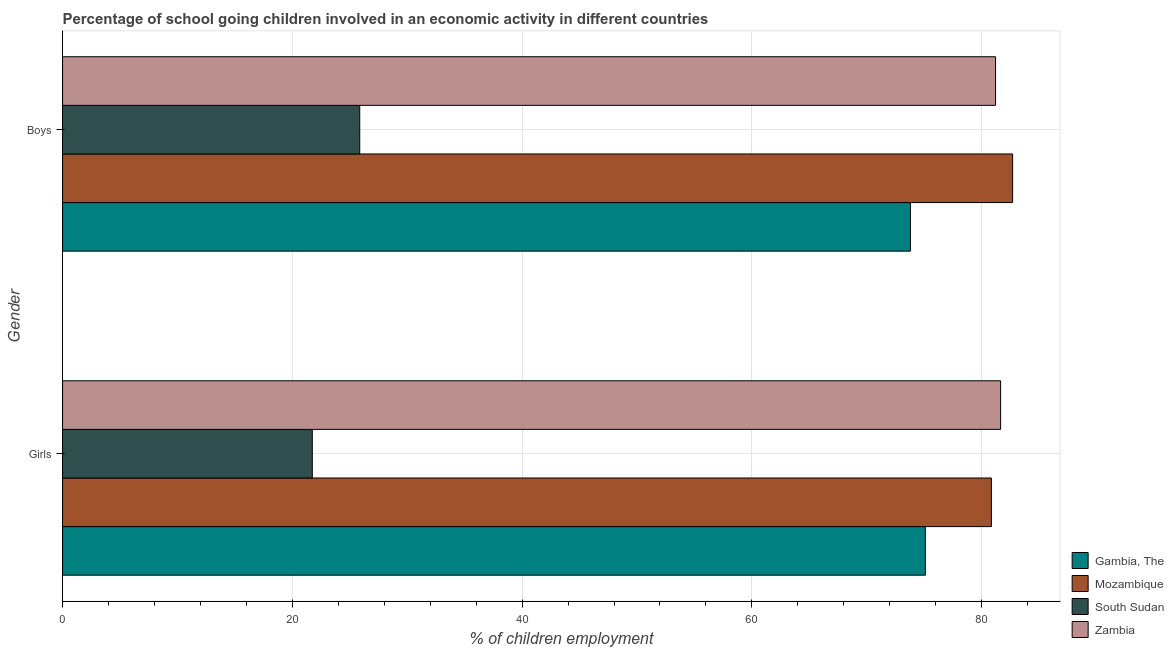How many different coloured bars are there?
Provide a short and direct response. 4. How many groups of bars are there?
Your response must be concise. 2. How many bars are there on the 2nd tick from the top?
Ensure brevity in your answer.  4. What is the label of the 2nd group of bars from the top?
Your answer should be compact. Girls. What is the percentage of school going girls in Gambia, The?
Your answer should be very brief. 75.1. Across all countries, what is the maximum percentage of school going girls?
Give a very brief answer. 81.65. Across all countries, what is the minimum percentage of school going girls?
Offer a terse response. 21.74. In which country was the percentage of school going girls maximum?
Provide a short and direct response. Zambia. In which country was the percentage of school going girls minimum?
Provide a short and direct response. South Sudan. What is the total percentage of school going girls in the graph?
Provide a succinct answer. 259.34. What is the difference between the percentage of school going girls in Gambia, The and that in Mozambique?
Keep it short and to the point. -5.75. What is the difference between the percentage of school going girls in South Sudan and the percentage of school going boys in Gambia, The?
Ensure brevity in your answer.  -52.06. What is the average percentage of school going boys per country?
Make the answer very short. 65.89. What is the difference between the percentage of school going boys and percentage of school going girls in Zambia?
Offer a very short reply. -0.44. What is the ratio of the percentage of school going boys in Mozambique to that in Zambia?
Offer a terse response. 1.02. Is the percentage of school going girls in Mozambique less than that in South Sudan?
Make the answer very short. No. What does the 4th bar from the top in Girls represents?
Offer a terse response. Gambia, The. What does the 3rd bar from the bottom in Girls represents?
Offer a terse response. South Sudan. How many bars are there?
Your answer should be very brief. 8. Are all the bars in the graph horizontal?
Keep it short and to the point. Yes. How many countries are there in the graph?
Make the answer very short. 4. Are the values on the major ticks of X-axis written in scientific E-notation?
Your response must be concise. No. Does the graph contain grids?
Offer a terse response. Yes. Where does the legend appear in the graph?
Make the answer very short. Bottom right. How many legend labels are there?
Make the answer very short. 4. What is the title of the graph?
Offer a terse response. Percentage of school going children involved in an economic activity in different countries. Does "Nicaragua" appear as one of the legend labels in the graph?
Provide a succinct answer. No. What is the label or title of the X-axis?
Provide a short and direct response. % of children employment. What is the label or title of the Y-axis?
Give a very brief answer. Gender. What is the % of children employment in Gambia, The in Girls?
Keep it short and to the point. 75.1. What is the % of children employment of Mozambique in Girls?
Give a very brief answer. 80.85. What is the % of children employment in South Sudan in Girls?
Your answer should be very brief. 21.74. What is the % of children employment in Zambia in Girls?
Ensure brevity in your answer.  81.65. What is the % of children employment in Gambia, The in Boys?
Give a very brief answer. 73.8. What is the % of children employment in Mozambique in Boys?
Offer a terse response. 82.7. What is the % of children employment in South Sudan in Boys?
Provide a succinct answer. 25.87. What is the % of children employment of Zambia in Boys?
Give a very brief answer. 81.21. Across all Gender, what is the maximum % of children employment of Gambia, The?
Give a very brief answer. 75.1. Across all Gender, what is the maximum % of children employment of Mozambique?
Your answer should be very brief. 82.7. Across all Gender, what is the maximum % of children employment in South Sudan?
Keep it short and to the point. 25.87. Across all Gender, what is the maximum % of children employment of Zambia?
Keep it short and to the point. 81.65. Across all Gender, what is the minimum % of children employment in Gambia, The?
Your response must be concise. 73.8. Across all Gender, what is the minimum % of children employment of Mozambique?
Provide a succinct answer. 80.85. Across all Gender, what is the minimum % of children employment of South Sudan?
Provide a succinct answer. 21.74. Across all Gender, what is the minimum % of children employment in Zambia?
Keep it short and to the point. 81.21. What is the total % of children employment of Gambia, The in the graph?
Make the answer very short. 148.9. What is the total % of children employment of Mozambique in the graph?
Provide a succinct answer. 163.55. What is the total % of children employment of South Sudan in the graph?
Offer a terse response. 47.6. What is the total % of children employment in Zambia in the graph?
Keep it short and to the point. 162.86. What is the difference between the % of children employment of Mozambique in Girls and that in Boys?
Ensure brevity in your answer.  -1.85. What is the difference between the % of children employment in South Sudan in Girls and that in Boys?
Your answer should be compact. -4.13. What is the difference between the % of children employment of Zambia in Girls and that in Boys?
Provide a succinct answer. 0.44. What is the difference between the % of children employment of Gambia, The in Girls and the % of children employment of Mozambique in Boys?
Offer a terse response. -7.6. What is the difference between the % of children employment of Gambia, The in Girls and the % of children employment of South Sudan in Boys?
Your answer should be compact. 49.23. What is the difference between the % of children employment of Gambia, The in Girls and the % of children employment of Zambia in Boys?
Offer a very short reply. -6.11. What is the difference between the % of children employment of Mozambique in Girls and the % of children employment of South Sudan in Boys?
Offer a terse response. 54.98. What is the difference between the % of children employment in Mozambique in Girls and the % of children employment in Zambia in Boys?
Offer a terse response. -0.36. What is the difference between the % of children employment in South Sudan in Girls and the % of children employment in Zambia in Boys?
Provide a succinct answer. -59.47. What is the average % of children employment in Gambia, The per Gender?
Keep it short and to the point. 74.45. What is the average % of children employment in Mozambique per Gender?
Your answer should be very brief. 81.77. What is the average % of children employment of South Sudan per Gender?
Your response must be concise. 23.8. What is the average % of children employment in Zambia per Gender?
Provide a succinct answer. 81.43. What is the difference between the % of children employment of Gambia, The and % of children employment of Mozambique in Girls?
Your response must be concise. -5.75. What is the difference between the % of children employment in Gambia, The and % of children employment in South Sudan in Girls?
Ensure brevity in your answer.  53.36. What is the difference between the % of children employment in Gambia, The and % of children employment in Zambia in Girls?
Give a very brief answer. -6.55. What is the difference between the % of children employment of Mozambique and % of children employment of South Sudan in Girls?
Offer a very short reply. 59.11. What is the difference between the % of children employment of Mozambique and % of children employment of Zambia in Girls?
Your answer should be very brief. -0.8. What is the difference between the % of children employment of South Sudan and % of children employment of Zambia in Girls?
Offer a very short reply. -59.92. What is the difference between the % of children employment in Gambia, The and % of children employment in Mozambique in Boys?
Ensure brevity in your answer.  -8.9. What is the difference between the % of children employment of Gambia, The and % of children employment of South Sudan in Boys?
Provide a short and direct response. 47.93. What is the difference between the % of children employment of Gambia, The and % of children employment of Zambia in Boys?
Your response must be concise. -7.41. What is the difference between the % of children employment of Mozambique and % of children employment of South Sudan in Boys?
Your answer should be compact. 56.83. What is the difference between the % of children employment in Mozambique and % of children employment in Zambia in Boys?
Give a very brief answer. 1.49. What is the difference between the % of children employment of South Sudan and % of children employment of Zambia in Boys?
Give a very brief answer. -55.34. What is the ratio of the % of children employment in Gambia, The in Girls to that in Boys?
Offer a very short reply. 1.02. What is the ratio of the % of children employment of Mozambique in Girls to that in Boys?
Provide a short and direct response. 0.98. What is the ratio of the % of children employment of South Sudan in Girls to that in Boys?
Make the answer very short. 0.84. What is the ratio of the % of children employment of Zambia in Girls to that in Boys?
Ensure brevity in your answer.  1.01. What is the difference between the highest and the second highest % of children employment in Gambia, The?
Your answer should be compact. 1.3. What is the difference between the highest and the second highest % of children employment of Mozambique?
Provide a short and direct response. 1.85. What is the difference between the highest and the second highest % of children employment in South Sudan?
Provide a succinct answer. 4.13. What is the difference between the highest and the second highest % of children employment of Zambia?
Your answer should be very brief. 0.44. What is the difference between the highest and the lowest % of children employment of Mozambique?
Your response must be concise. 1.85. What is the difference between the highest and the lowest % of children employment of South Sudan?
Offer a terse response. 4.13. What is the difference between the highest and the lowest % of children employment of Zambia?
Keep it short and to the point. 0.44. 